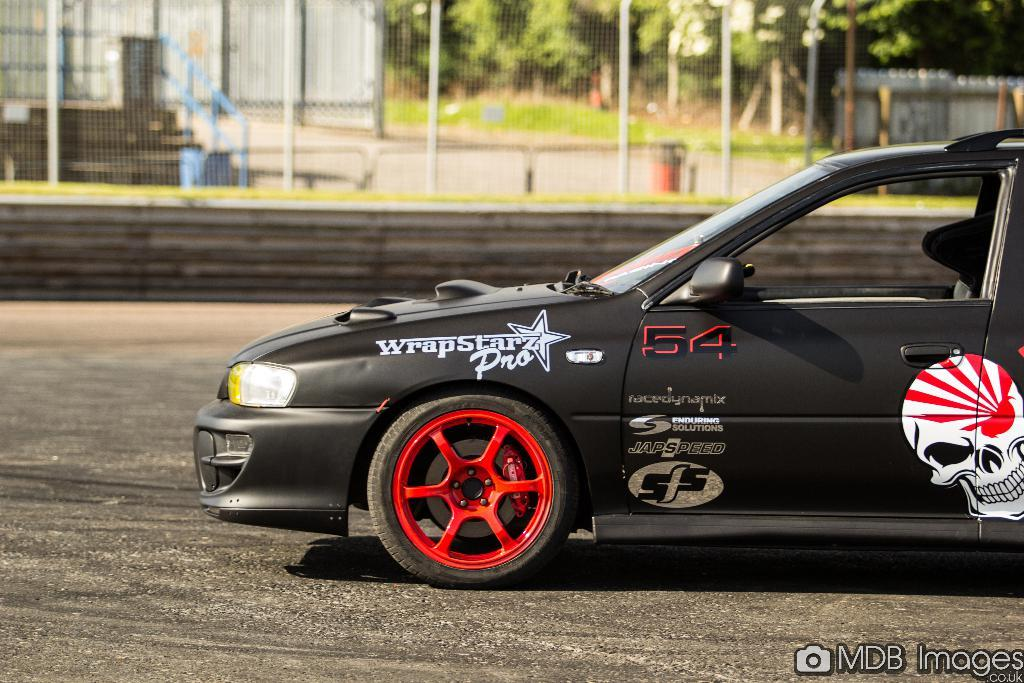What is the main subject of the image? There is a car in the image. Where is the car located? The car is on the road. What can be seen in the background of the image? There is fencing, trees, and grass in the background of the image. How many jellyfish are swimming in the grass in the image? There are no jellyfish present in the image, and jellyfish cannot swim in grass. 